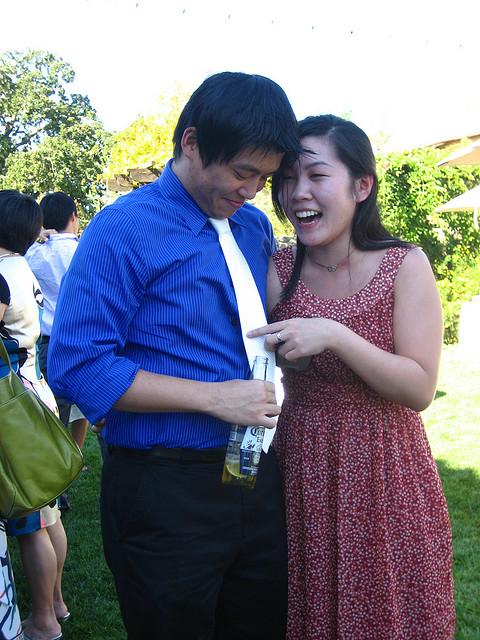What country is the beer from?
Be succinct. Mexico. What color is the man's tie?
Answer briefly. White. What type of beer is he holding?
Be succinct. Corona. 